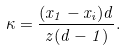<formula> <loc_0><loc_0><loc_500><loc_500>\kappa = \frac { ( x _ { 1 } - x _ { i } ) d } { z ( d - 1 ) } .</formula> 